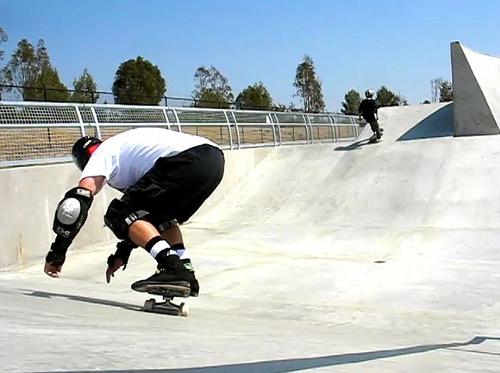What is on the man's arm?
Answer briefly. Elbow pad. What type of place is the man skateboarding?
Quick response, please. Skate park. What is this man doing?
Short answer required. Skateboarding. 